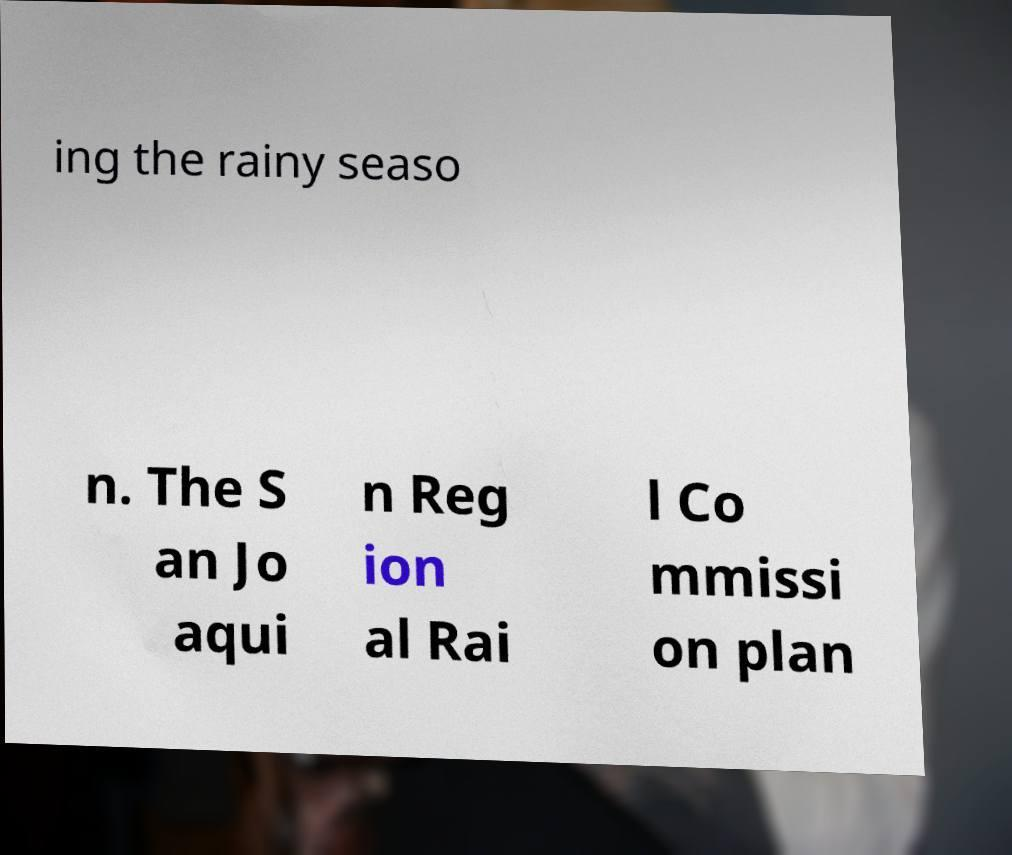Please identify and transcribe the text found in this image. ing the rainy seaso n. The S an Jo aqui n Reg ion al Rai l Co mmissi on plan 